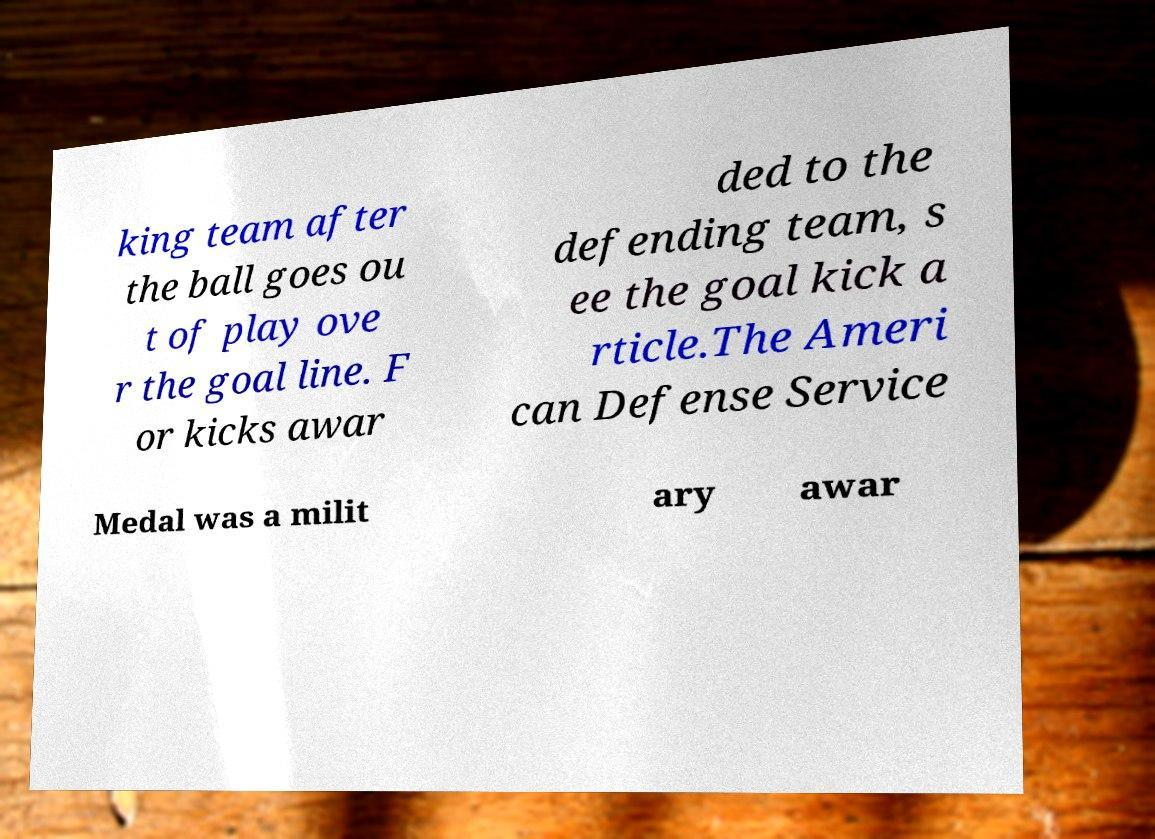Please identify and transcribe the text found in this image. king team after the ball goes ou t of play ove r the goal line. F or kicks awar ded to the defending team, s ee the goal kick a rticle.The Ameri can Defense Service Medal was a milit ary awar 